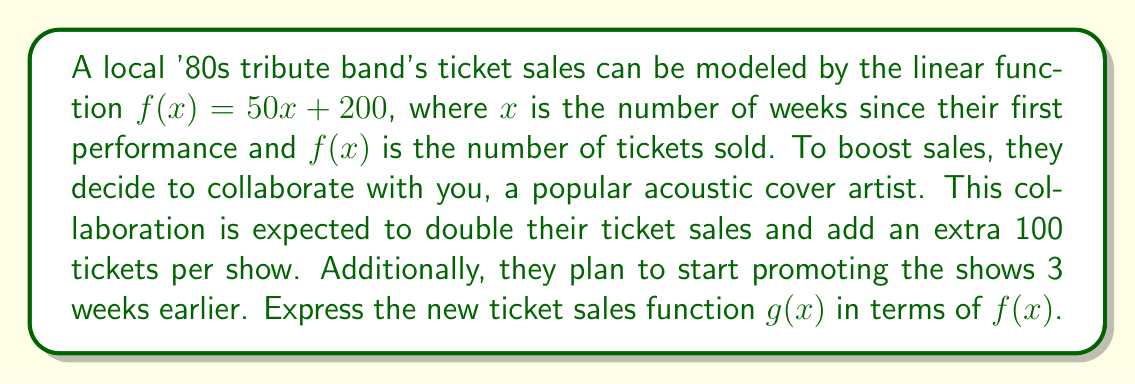What is the answer to this math problem? Let's break this down step-by-step:

1) First, we need to double the ticket sales. This is a vertical stretch by a factor of 2:
   $2f(x)$

2) Next, we add 100 extra tickets per show. This is a vertical shift up by 100:
   $2f(x) + 100$

3) Finally, we start promoting 3 weeks earlier. This is a horizontal shift left by 3:
   $2f(x + 3) + 100$

4) Therefore, our new function $g(x)$ can be expressed as:
   $g(x) = 2f(x + 3) + 100$

5) To verify, let's expand this using the original function $f(x) = 50x + 200$:
   $g(x) = 2(50(x + 3) + 200) + 100$
   $g(x) = 2(50x + 150 + 200) + 100$
   $g(x) = 2(50x + 350) + 100$
   $g(x) = 100x + 700 + 100$
   $g(x) = 100x + 800$

This final form shows how the slope has doubled (from 50 to 100) and the y-intercept has increased (from 200 to 800), reflecting the changes in ticket sales.
Answer: $g(x) = 2f(x + 3) + 100$ 